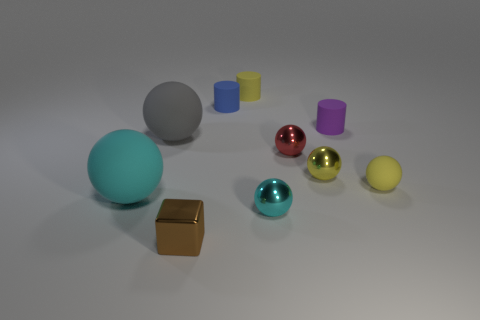Subtract all small yellow metallic spheres. How many spheres are left? 5 Subtract all red balls. How many balls are left? 5 Subtract all gray spheres. Subtract all gray cylinders. How many spheres are left? 5 Subtract all spheres. How many objects are left? 4 Subtract all big yellow metal things. Subtract all large cyan spheres. How many objects are left? 9 Add 8 purple rubber cylinders. How many purple rubber cylinders are left? 9 Add 1 large gray rubber spheres. How many large gray rubber spheres exist? 2 Subtract 0 brown cylinders. How many objects are left? 10 